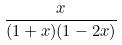Convert formula to latex. <formula><loc_0><loc_0><loc_500><loc_500>\frac { x } { ( 1 + x ) ( 1 - 2 x ) }</formula> 